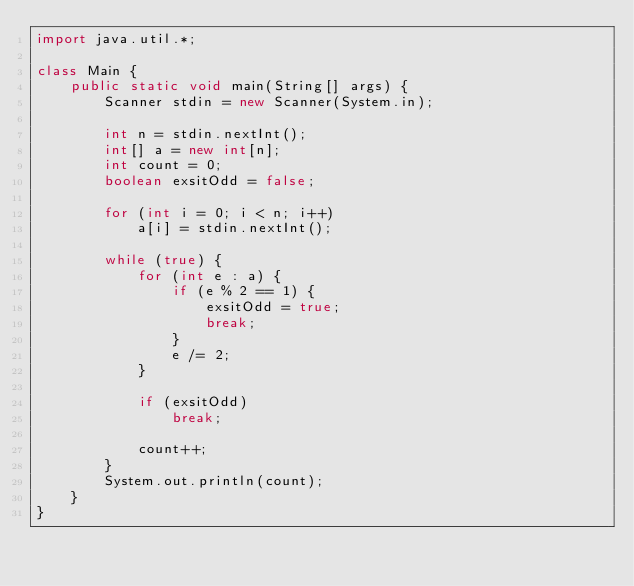Convert code to text. <code><loc_0><loc_0><loc_500><loc_500><_Java_>import java.util.*;

class Main {
    public static void main(String[] args) {
        Scanner stdin = new Scanner(System.in);

        int n = stdin.nextInt();
        int[] a = new int[n];
        int count = 0;
        boolean exsitOdd = false;

        for (int i = 0; i < n; i++)
            a[i] = stdin.nextInt();

        while (true) {
            for (int e : a) {
                if (e % 2 == 1) {
                    exsitOdd = true;
                    break;
                }
                e /= 2;
            }

            if (exsitOdd)
                break;

            count++;
        }
        System.out.println(count);
    }
}</code> 